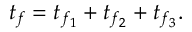<formula> <loc_0><loc_0><loc_500><loc_500>t _ { f } = t _ { f _ { 1 } } + t _ { f _ { 2 } } + t _ { f _ { 3 } } .</formula> 